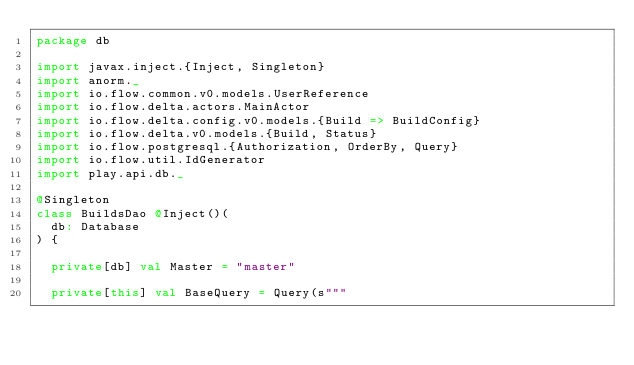<code> <loc_0><loc_0><loc_500><loc_500><_Scala_>package db

import javax.inject.{Inject, Singleton}
import anorm._
import io.flow.common.v0.models.UserReference
import io.flow.delta.actors.MainActor
import io.flow.delta.config.v0.models.{Build => BuildConfig}
import io.flow.delta.v0.models.{Build, Status}
import io.flow.postgresql.{Authorization, OrderBy, Query}
import io.flow.util.IdGenerator
import play.api.db._

@Singleton
class BuildsDao @Inject()(
  db: Database
) {

  private[db] val Master = "master"

  private[this] val BaseQuery = Query(s"""</code> 